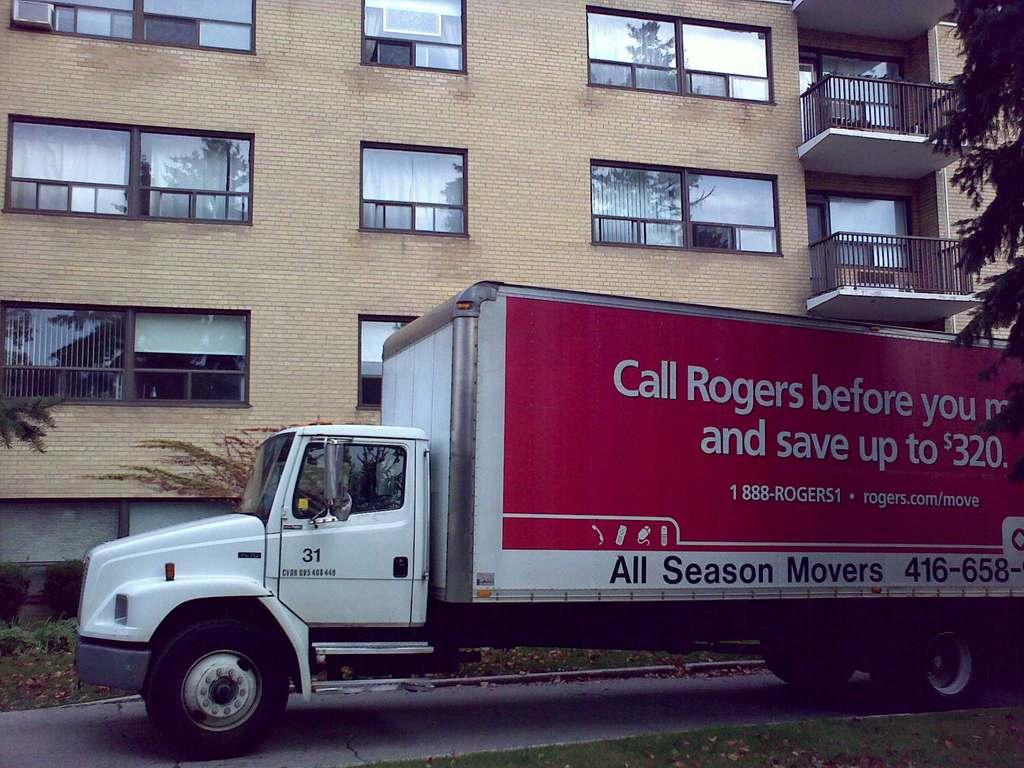What is the main subject in the center of the image? There is a truck in the center of the image. Where is the truck located? The truck is on the road. What can be seen in the background of the image? There are buildings and trees visible in the background of the image. What type of vegetation is at the bottom of the image? There is grass at the bottom of the image. What type of silk fabric is draped over the arch in the image? There is no silk fabric or arch present in the image. 